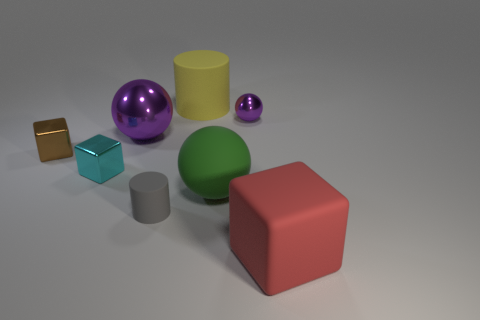Is there a green object on the left side of the cylinder behind the large green rubber object? no 